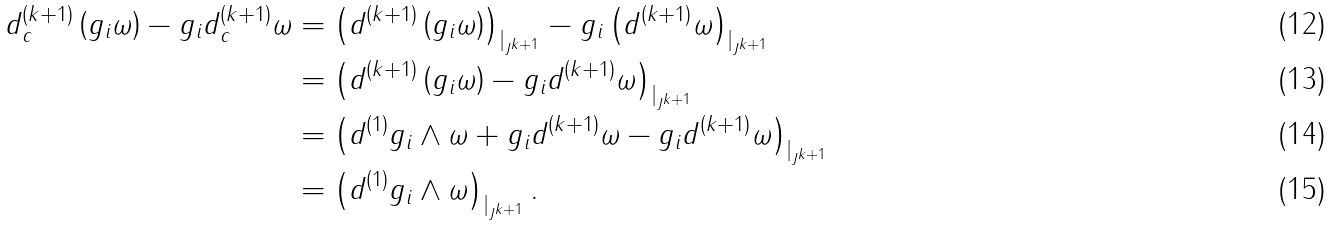<formula> <loc_0><loc_0><loc_500><loc_500>d _ { c } ^ { ( k + 1 ) } \left ( g _ { i } \omega \right ) - g _ { i } d _ { c } ^ { ( k + 1 ) } \omega & = \left ( d ^ { ( k + 1 ) } \left ( g _ { i } \omega \right ) \right ) _ { | _ { J ^ { k + 1 } } } - g _ { i } \left ( d ^ { ( k + 1 ) } \omega \right ) _ { | _ { J ^ { k + 1 } } } \\ & = \left ( d ^ { ( k + 1 ) } \left ( g _ { i } \omega \right ) - g _ { i } d ^ { ( k + 1 ) } \omega \right ) _ { | _ { J ^ { k + 1 } } } \\ & = \left ( d ^ { ( 1 ) } g _ { i } \wedge \omega + g _ { i } d ^ { ( k + 1 ) } \omega - g _ { i } d ^ { ( k + 1 ) } \omega \right ) _ { | _ { J ^ { k + 1 } } } \\ & = \left ( d ^ { ( 1 ) } g _ { i } \wedge \omega \right ) _ { | _ { J ^ { k + 1 } } } .</formula> 